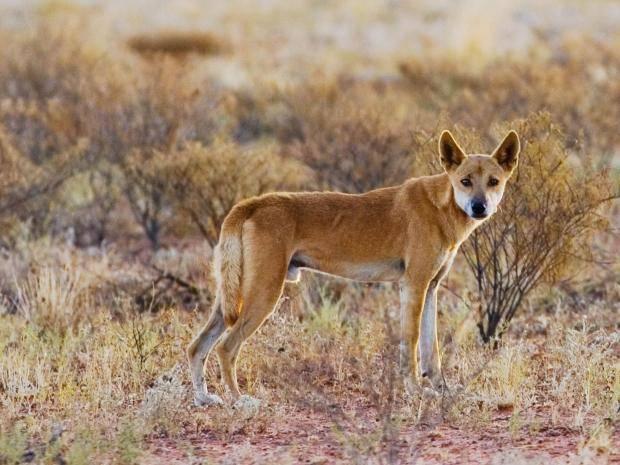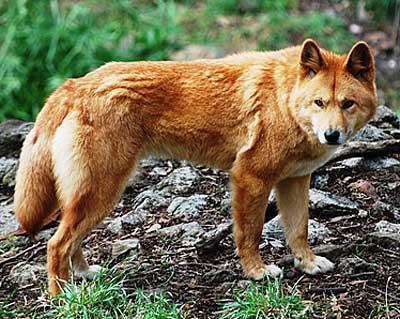The first image is the image on the left, the second image is the image on the right. Assess this claim about the two images: "At least one image includes a dog standing with head facing the camera.". Correct or not? Answer yes or no. Yes. The first image is the image on the left, the second image is the image on the right. Given the left and right images, does the statement "The background of the image on the left is brown" hold true? Answer yes or no. Yes. 